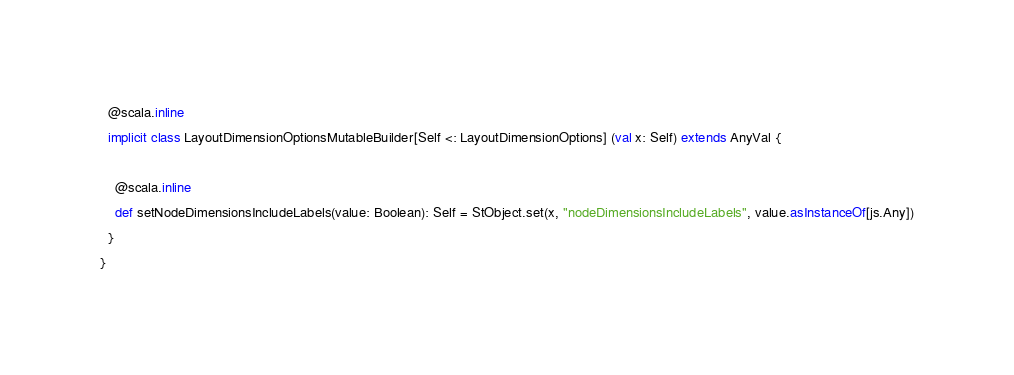Convert code to text. <code><loc_0><loc_0><loc_500><loc_500><_Scala_>  @scala.inline
  implicit class LayoutDimensionOptionsMutableBuilder[Self <: LayoutDimensionOptions] (val x: Self) extends AnyVal {
    
    @scala.inline
    def setNodeDimensionsIncludeLabels(value: Boolean): Self = StObject.set(x, "nodeDimensionsIncludeLabels", value.asInstanceOf[js.Any])
  }
}
</code> 